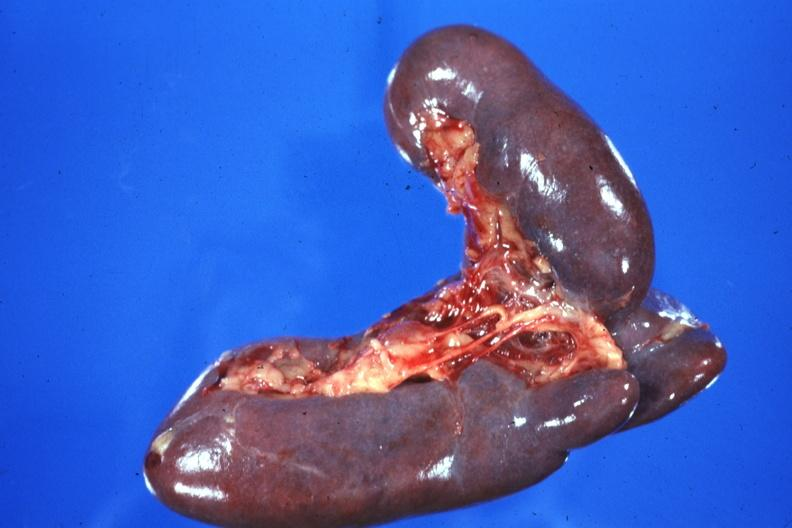s mucinous cystadenocarcinoma present?
Answer the question using a single word or phrase. No 